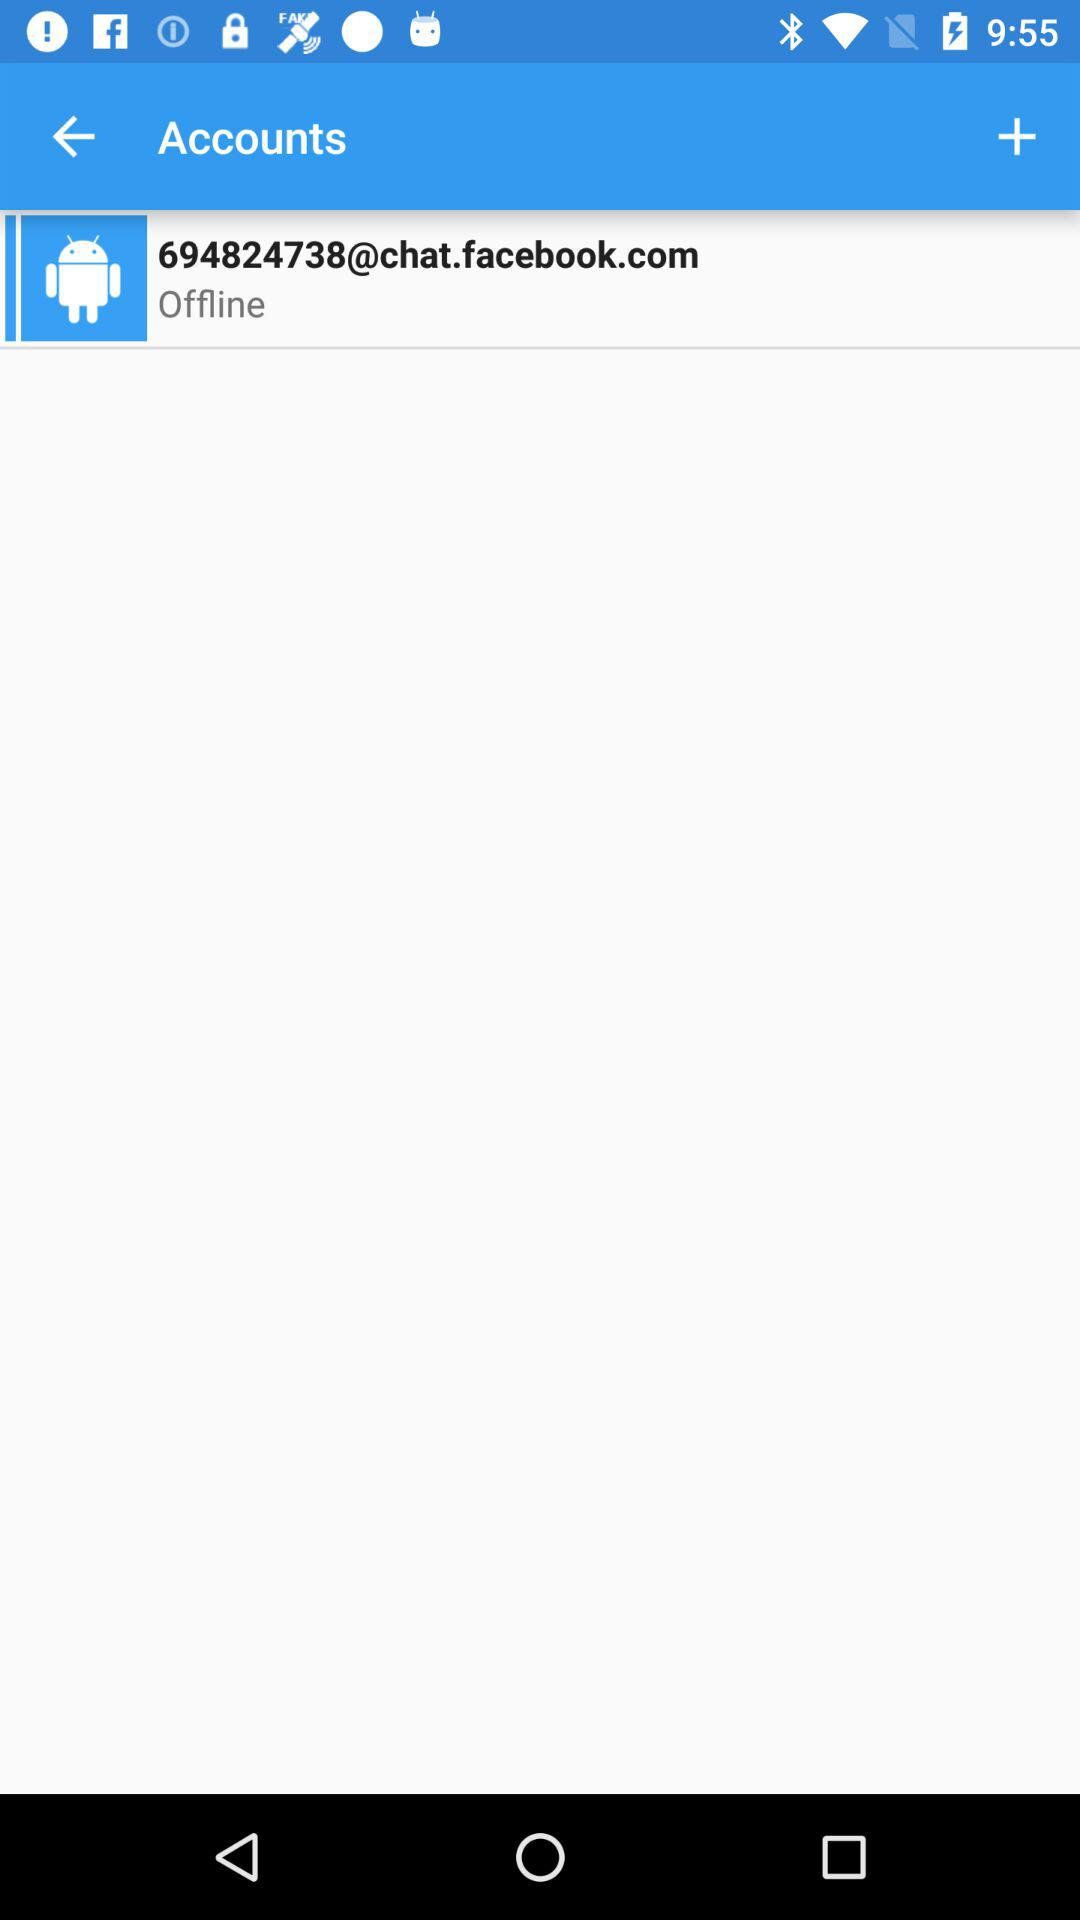What is the email address for the account? The email address is 694824738@chat.facebook.com. 